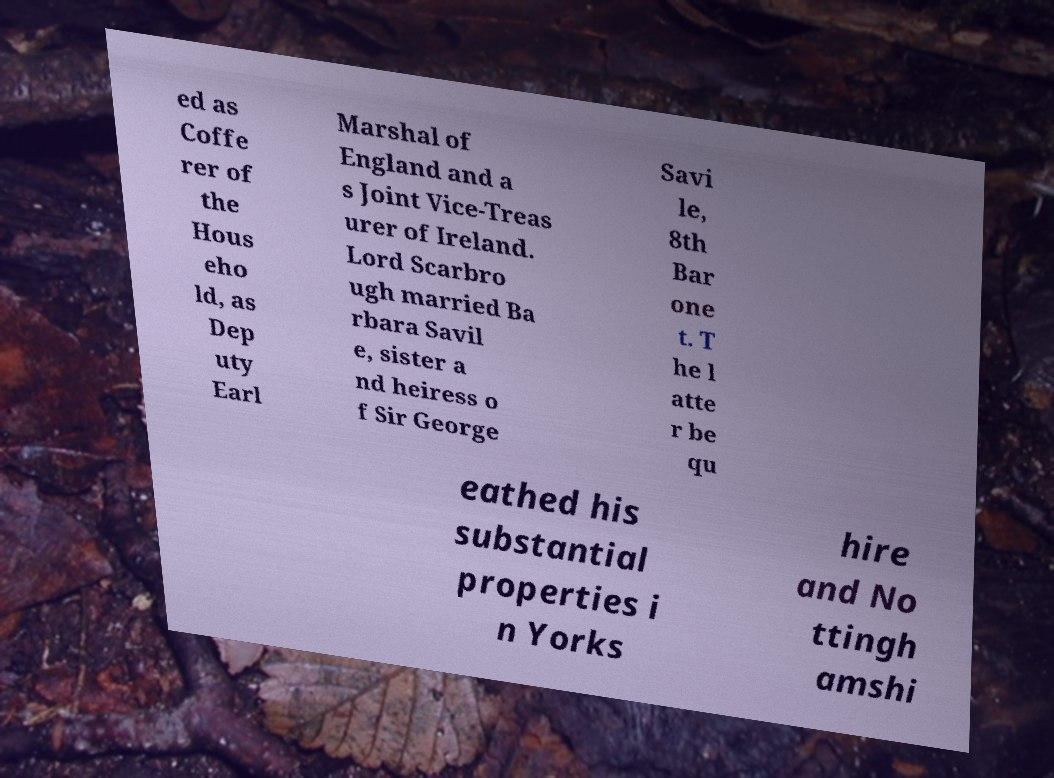For documentation purposes, I need the text within this image transcribed. Could you provide that? ed as Coffe rer of the Hous eho ld, as Dep uty Earl Marshal of England and a s Joint Vice-Treas urer of Ireland. Lord Scarbro ugh married Ba rbara Savil e, sister a nd heiress o f Sir George Savi le, 8th Bar one t. T he l atte r be qu eathed his substantial properties i n Yorks hire and No ttingh amshi 